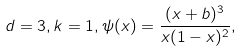Convert formula to latex. <formula><loc_0><loc_0><loc_500><loc_500>d = 3 , k = 1 , \psi ( x ) = \frac { ( x + b ) ^ { 3 } } { x ( 1 - x ) ^ { 2 } } ,</formula> 